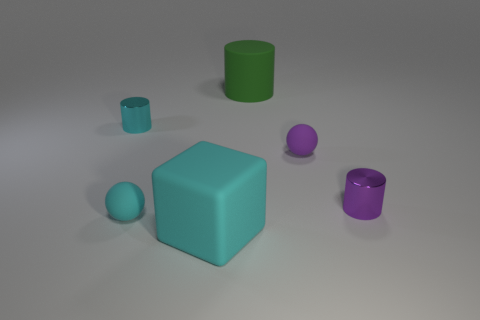What material is the ball on the left side of the rubber cylinder behind the metal cylinder to the left of the purple cylinder made of?
Ensure brevity in your answer.  Rubber. How many objects are objects that are in front of the small purple rubber ball or big rubber things that are on the left side of the large matte cylinder?
Ensure brevity in your answer.  3. There is a green thing that is the same shape as the cyan shiny object; what is its material?
Ensure brevity in your answer.  Rubber. What number of shiny things are tiny cyan cylinders or tiny yellow spheres?
Your answer should be very brief. 1. There is a tiny purple thing that is the same material as the cyan sphere; what is its shape?
Offer a very short reply. Sphere. What number of green matte things have the same shape as the purple matte thing?
Ensure brevity in your answer.  0. There is a rubber object on the right side of the large matte cylinder; is its shape the same as the large rubber object behind the cyan cylinder?
Ensure brevity in your answer.  No. What number of things are blue balls or small shiny cylinders on the left side of the purple metallic cylinder?
Provide a short and direct response. 1. What is the shape of the metallic object that is the same color as the big cube?
Give a very brief answer. Cylinder. What number of purple rubber balls are the same size as the rubber cube?
Provide a short and direct response. 0. 